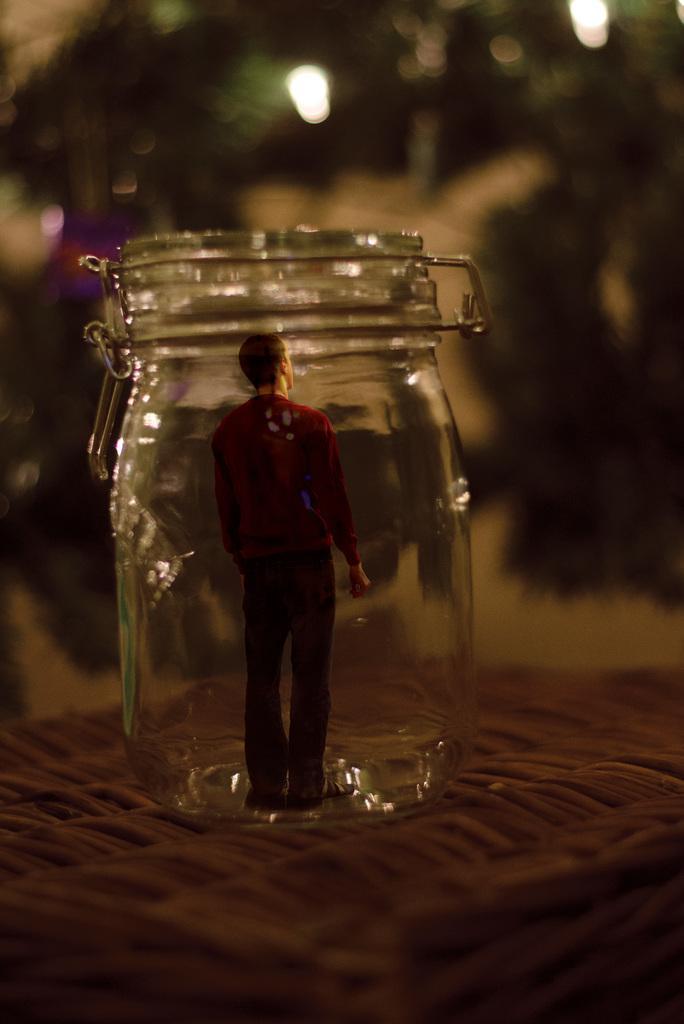Can you describe this image briefly? In this image I can see a toy in a mason jar. The background is blurred. 